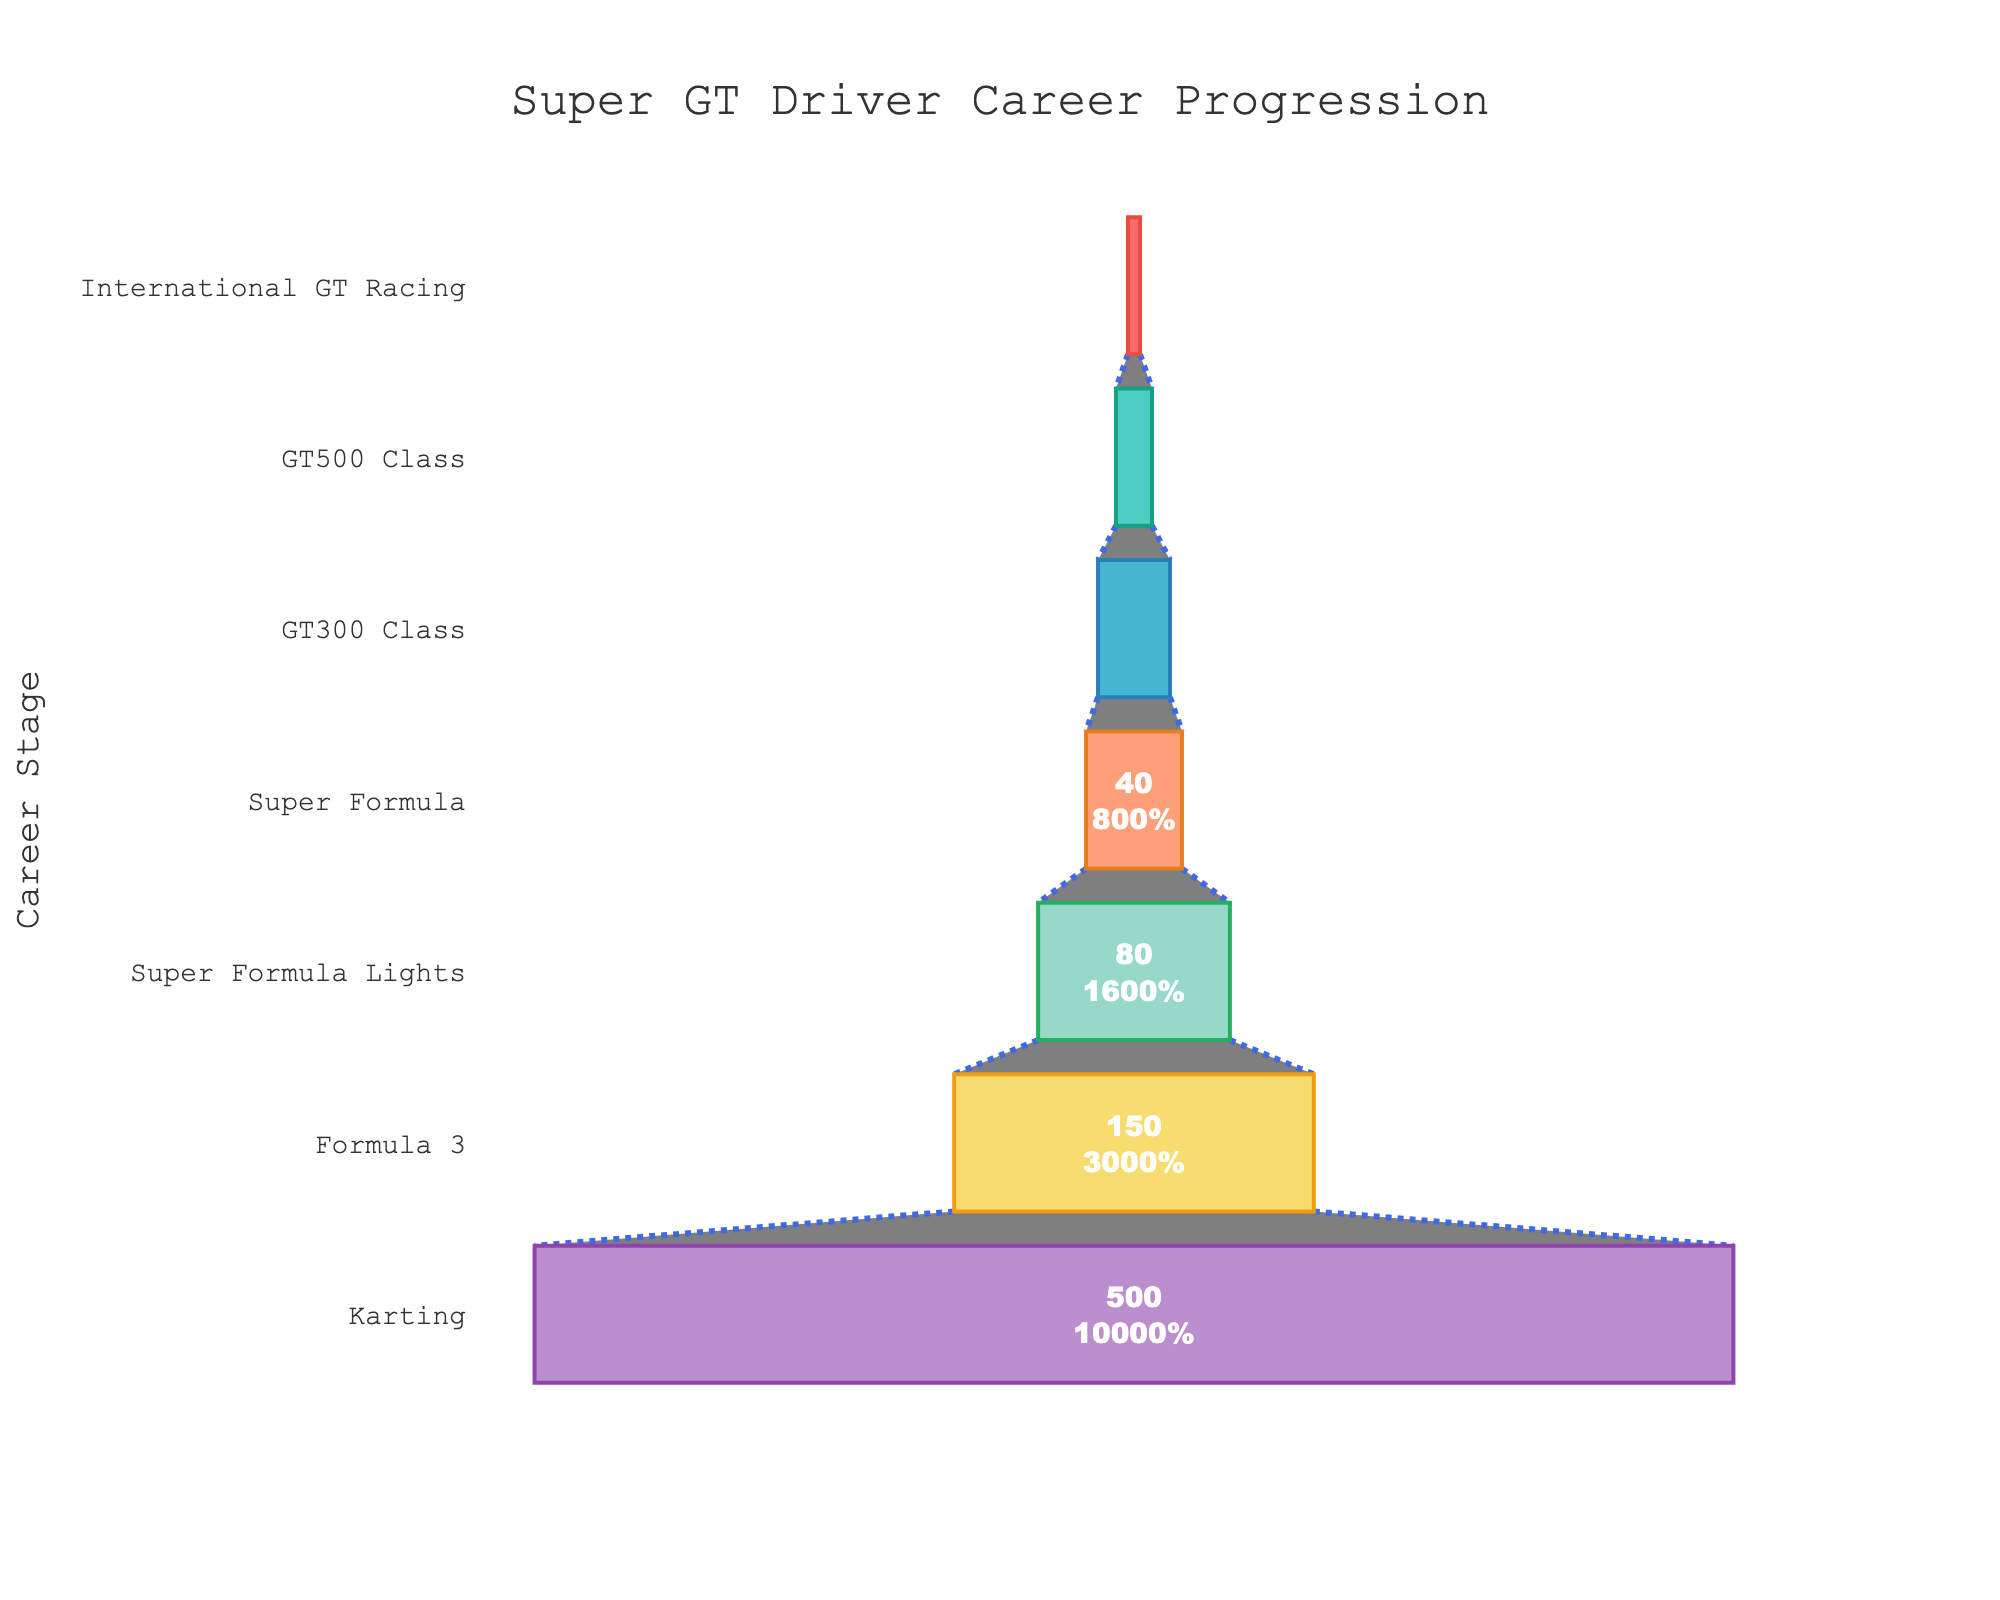Which career stage has the highest number of drivers? By referring to the topmost section of the funnel chart, the stage with the highest number of drivers is identified.
Answer: Karting How many drivers progressed to Formula 3 from Karting? From the funnel chart, we can observe the drop in the number of drivers from Karting to Formula 3 by comparing their respective values.
Answer: 150 What percentage of drivers moved from Super Formula Lights to Super Formula? The funnel chart shows the number of drivers at each stage and the percentage transition. The percentage from Super Formula Lights (80 drivers) to Super Formula (40 drivers) is 50%.
Answer: 50% How many stages are there in the Super GT driver career progression funnel chart? Count the number of distinct stages present in the funnel chart.
Answer: 7 What is the title of the funnel chart? The title is found at the top of the funnel chart.
Answer: Super GT Driver Career Progression How much difference is there between the number of drivers in GT300 Class and GT500 Class? Subtract the number of drivers in GT500 Class (15) from the number of drivers in GT300 Class (30).
Answer: 15 Which stage records the smallest number of drivers? Look at the smallest funnel segment which represents the stage with the fewest drivers.
Answer: International GT Racing Compare the number of drivers in the first and the last stages. Compare the drivers' numbers in Karting (500) and International GT Racing (5).
Answer: Karting has 95 times more drivers than International GT Racing What color is used for the Karting stage in the funnel chart? Identify the color corresponding to the top segment (Karting) in the funnel chart.
Answer: Red Which stage has a higher percentage drop in the number of drivers: from Karting to Formula 3 or from Formula 3 to Super Formula Lights? Calculate the percentage drop for both transitions: Karting to Formula 3 (500 to 150, a 70% drop) and Formula 3 to Super Formula Lights (150 to 80, a 47% drop).
Answer: Karting to Formula 3 